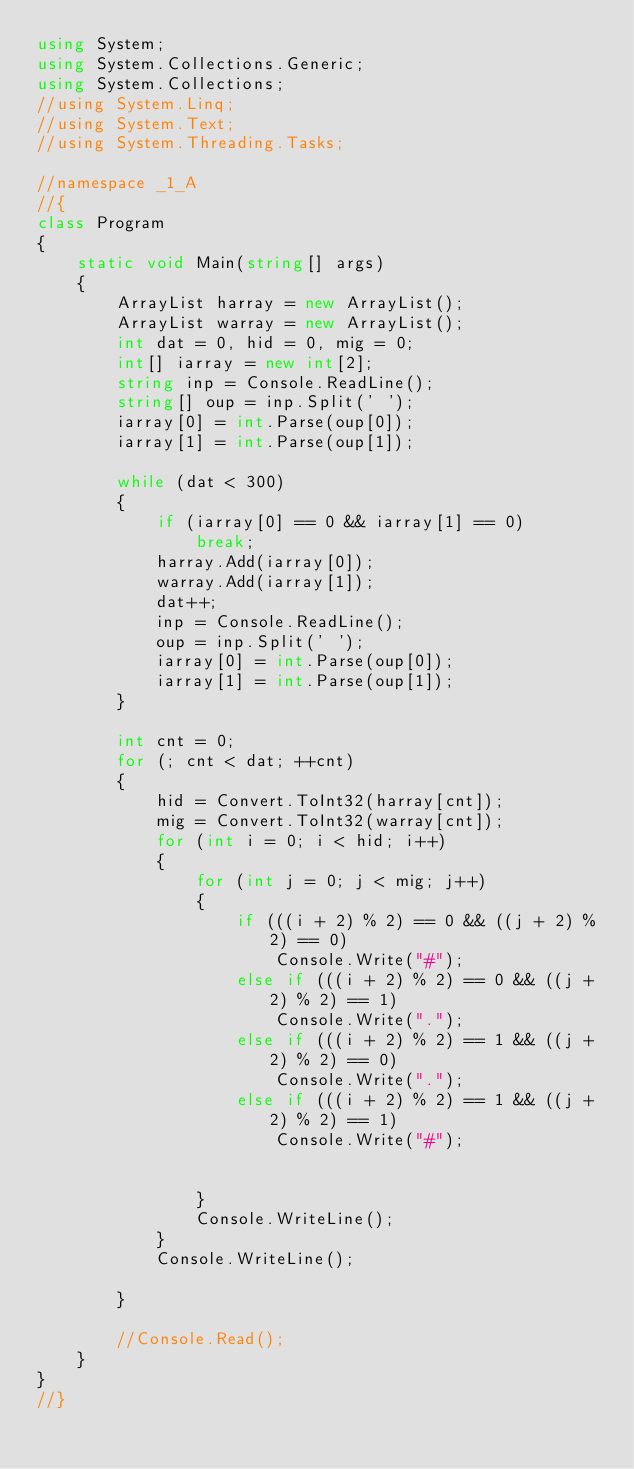<code> <loc_0><loc_0><loc_500><loc_500><_C#_>using System;
using System.Collections.Generic;
using System.Collections;
//using System.Linq;
//using System.Text;
//using System.Threading.Tasks;

//namespace _1_A
//{
class Program
{
    static void Main(string[] args)
    {
        ArrayList harray = new ArrayList();
        ArrayList warray = new ArrayList();
        int dat = 0, hid = 0, mig = 0;
        int[] iarray = new int[2];
        string inp = Console.ReadLine();
        string[] oup = inp.Split(' ');
        iarray[0] = int.Parse(oup[0]);
        iarray[1] = int.Parse(oup[1]);

        while (dat < 300)
        {
            if (iarray[0] == 0 && iarray[1] == 0)
                break;
            harray.Add(iarray[0]);
            warray.Add(iarray[1]);
            dat++;
            inp = Console.ReadLine();
            oup = inp.Split(' ');
            iarray[0] = int.Parse(oup[0]);
            iarray[1] = int.Parse(oup[1]);
        }

        int cnt = 0;
        for (; cnt < dat; ++cnt)
        {
            hid = Convert.ToInt32(harray[cnt]);
            mig = Convert.ToInt32(warray[cnt]);
            for (int i = 0; i < hid; i++)
            {
                for (int j = 0; j < mig; j++)
                {
                    if (((i + 2) % 2) == 0 && ((j + 2) % 2) == 0)
                        Console.Write("#");
                    else if (((i + 2) % 2) == 0 && ((j + 2) % 2) == 1)
                        Console.Write(".");
                    else if (((i + 2) % 2) == 1 && ((j + 2) % 2) == 0)
                        Console.Write(".");
                    else if (((i + 2) % 2) == 1 && ((j + 2) % 2) == 1)
                        Console.Write("#");


                }
                Console.WriteLine();
            }
            Console.WriteLine();

        }

        //Console.Read();
    }
}
//}</code> 